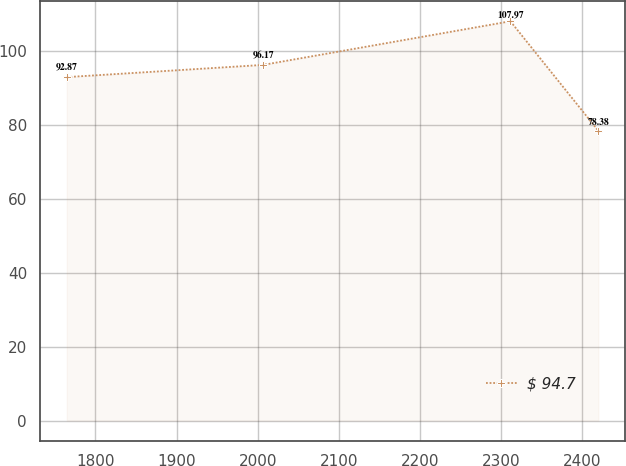Convert chart to OTSL. <chart><loc_0><loc_0><loc_500><loc_500><line_chart><ecel><fcel>$ 94.7<nl><fcel>1764.8<fcel>92.87<nl><fcel>2006.66<fcel>96.17<nl><fcel>2311.5<fcel>107.97<nl><fcel>2419.81<fcel>78.38<nl></chart> 